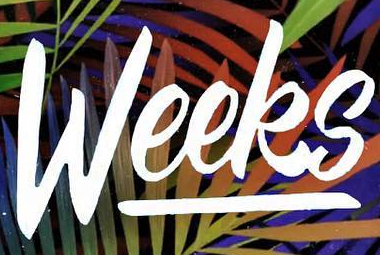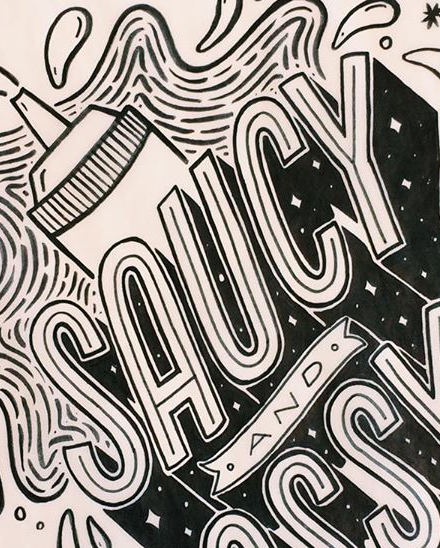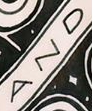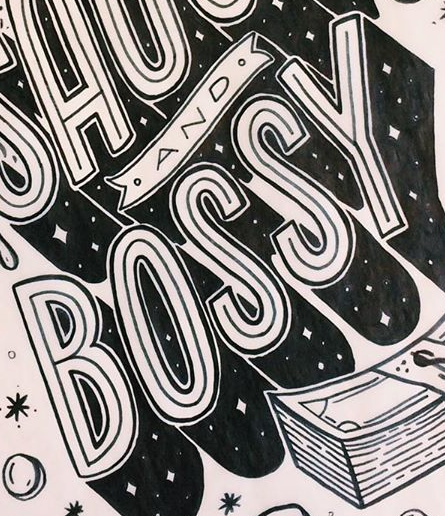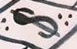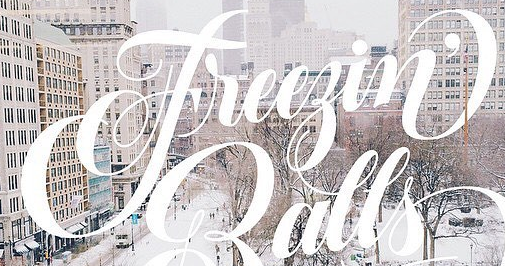Read the text from these images in sequence, separated by a semicolon. Weeks; SAUCY; AND; BOSSY; $; Freegin' 